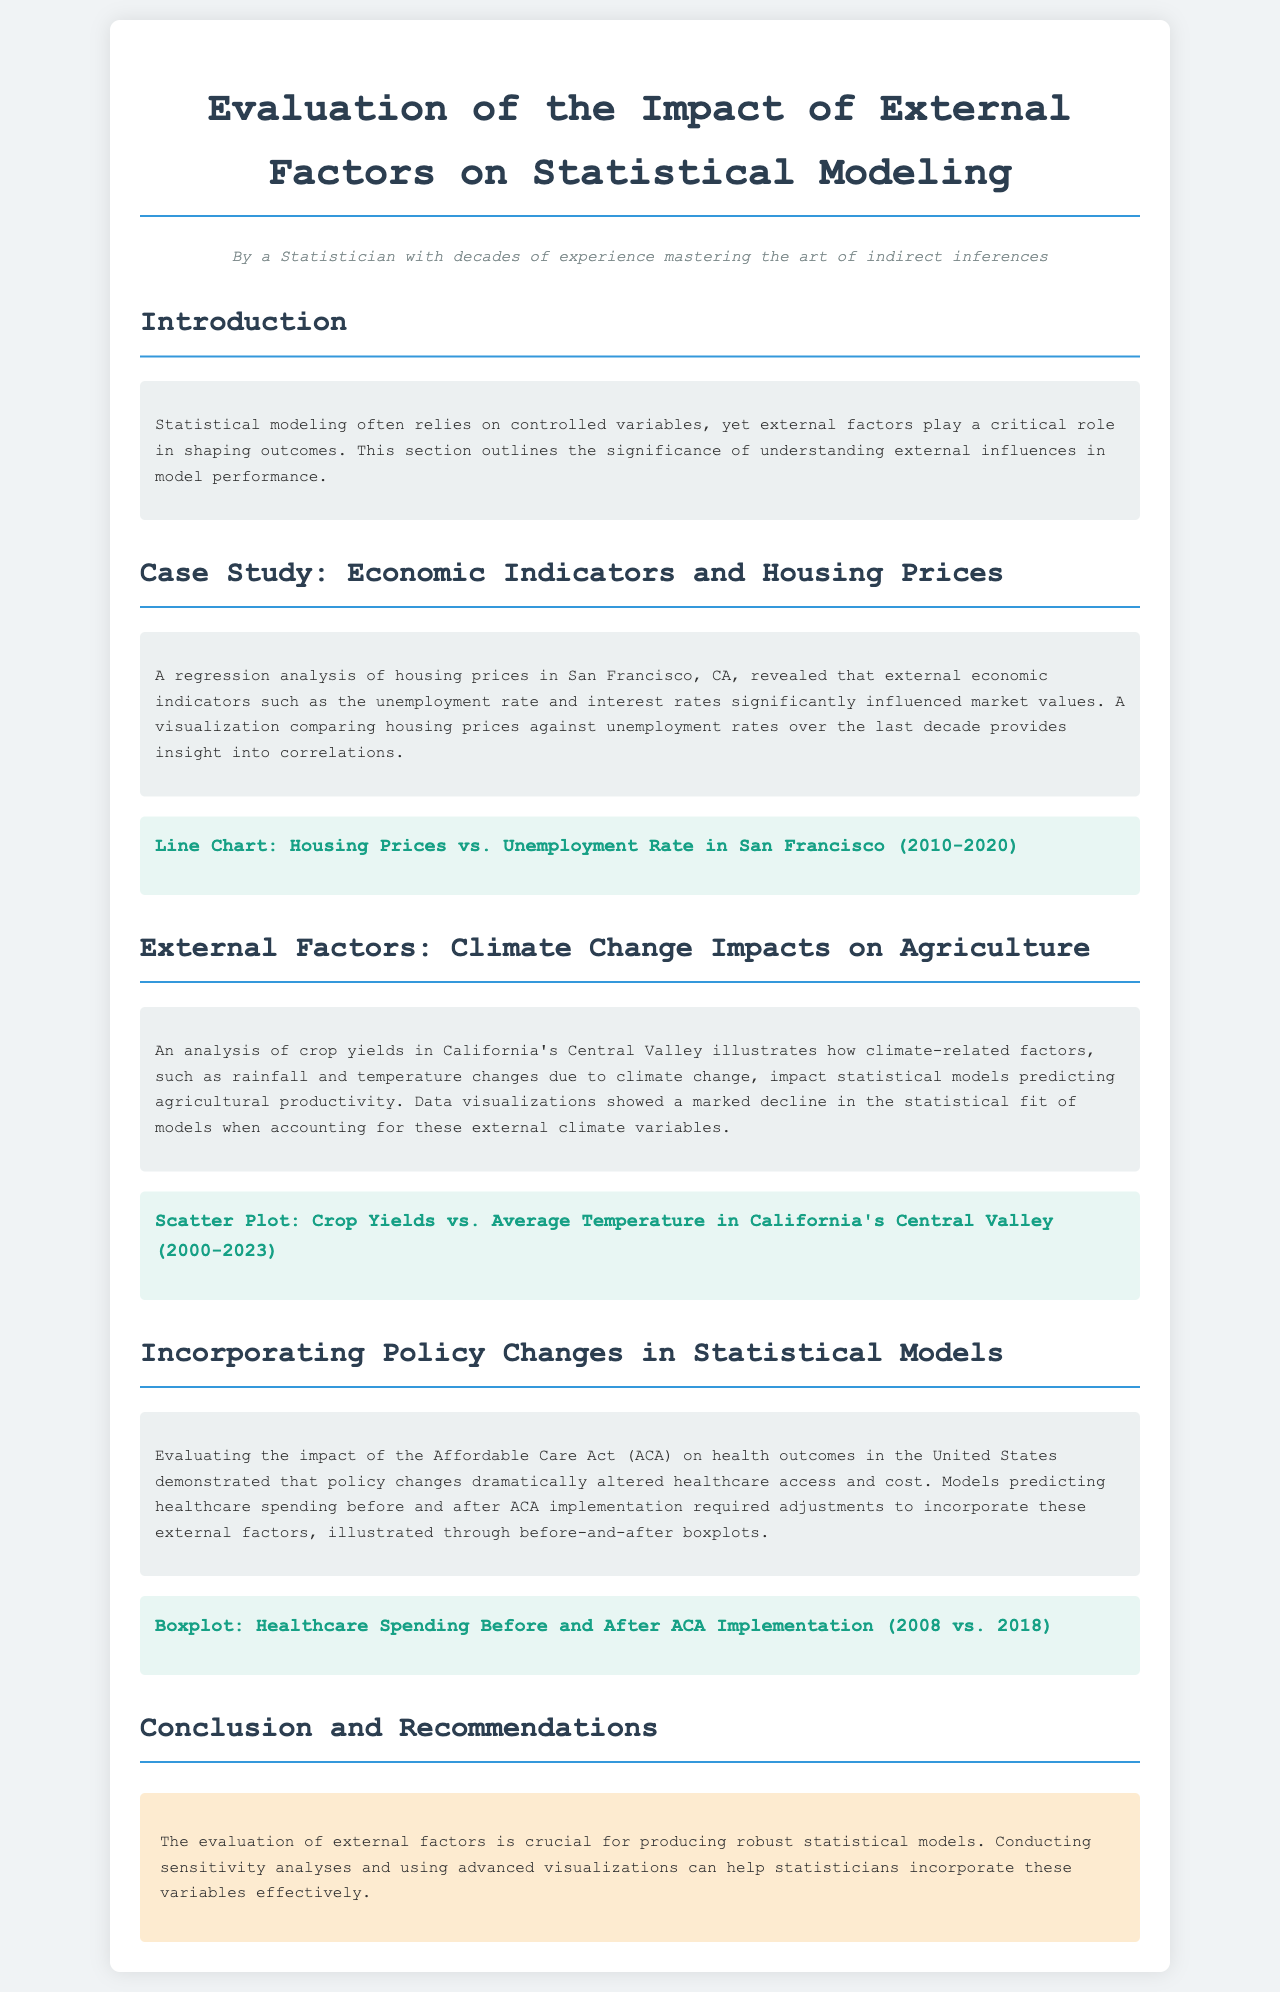What is the primary focus of the document? The document focuses on evaluating the impact of external factors on statistical modeling.
Answer: Evaluating the impact of external factors on statistical modeling What economic indicators influenced housing prices? The document mentions the unemployment rate and interest rates as significant external economic indicators.
Answer: Unemployment rate and interest rates What years are covered in the housing prices and unemployment rate visualization? The line chart covers housing prices and unemployment rates from 2010 to 2020 in San Francisco.
Answer: 2010-2020 Which federal policy is discussed in relation to health outcomes? The Affordable Care Act (ACA) is evaluated concerning its impact on healthcare outcomes.
Answer: Affordable Care Act (ACA) What type of visualization is used to illustrate healthcare spending changes? Before-and-after boxplots are used to illustrate changes in healthcare spending due to the ACA.
Answer: Boxplot What type of external factor is analyzed in relation to agriculture? Climate-related factors, such as rainfall and temperature changes due to climate change, are analyzed.
Answer: Climate-related factors What period does the crop yields' visualization cover? The scatter plot on crop yields versus average temperature covers the years from 2000 to 2023.
Answer: 2000-2023 What recommendation is made for statisticians concerning external factors? The document recommends conducting sensitivity analyses to effectively incorporate external variables in models.
Answer: Conducting sensitivity analyses What was the impact of climate change on agricultural productivity predictions? The analysis showed a marked decline in the statistical fit of models when accounting for climate variables.
Answer: Marked decline in statistical fit 